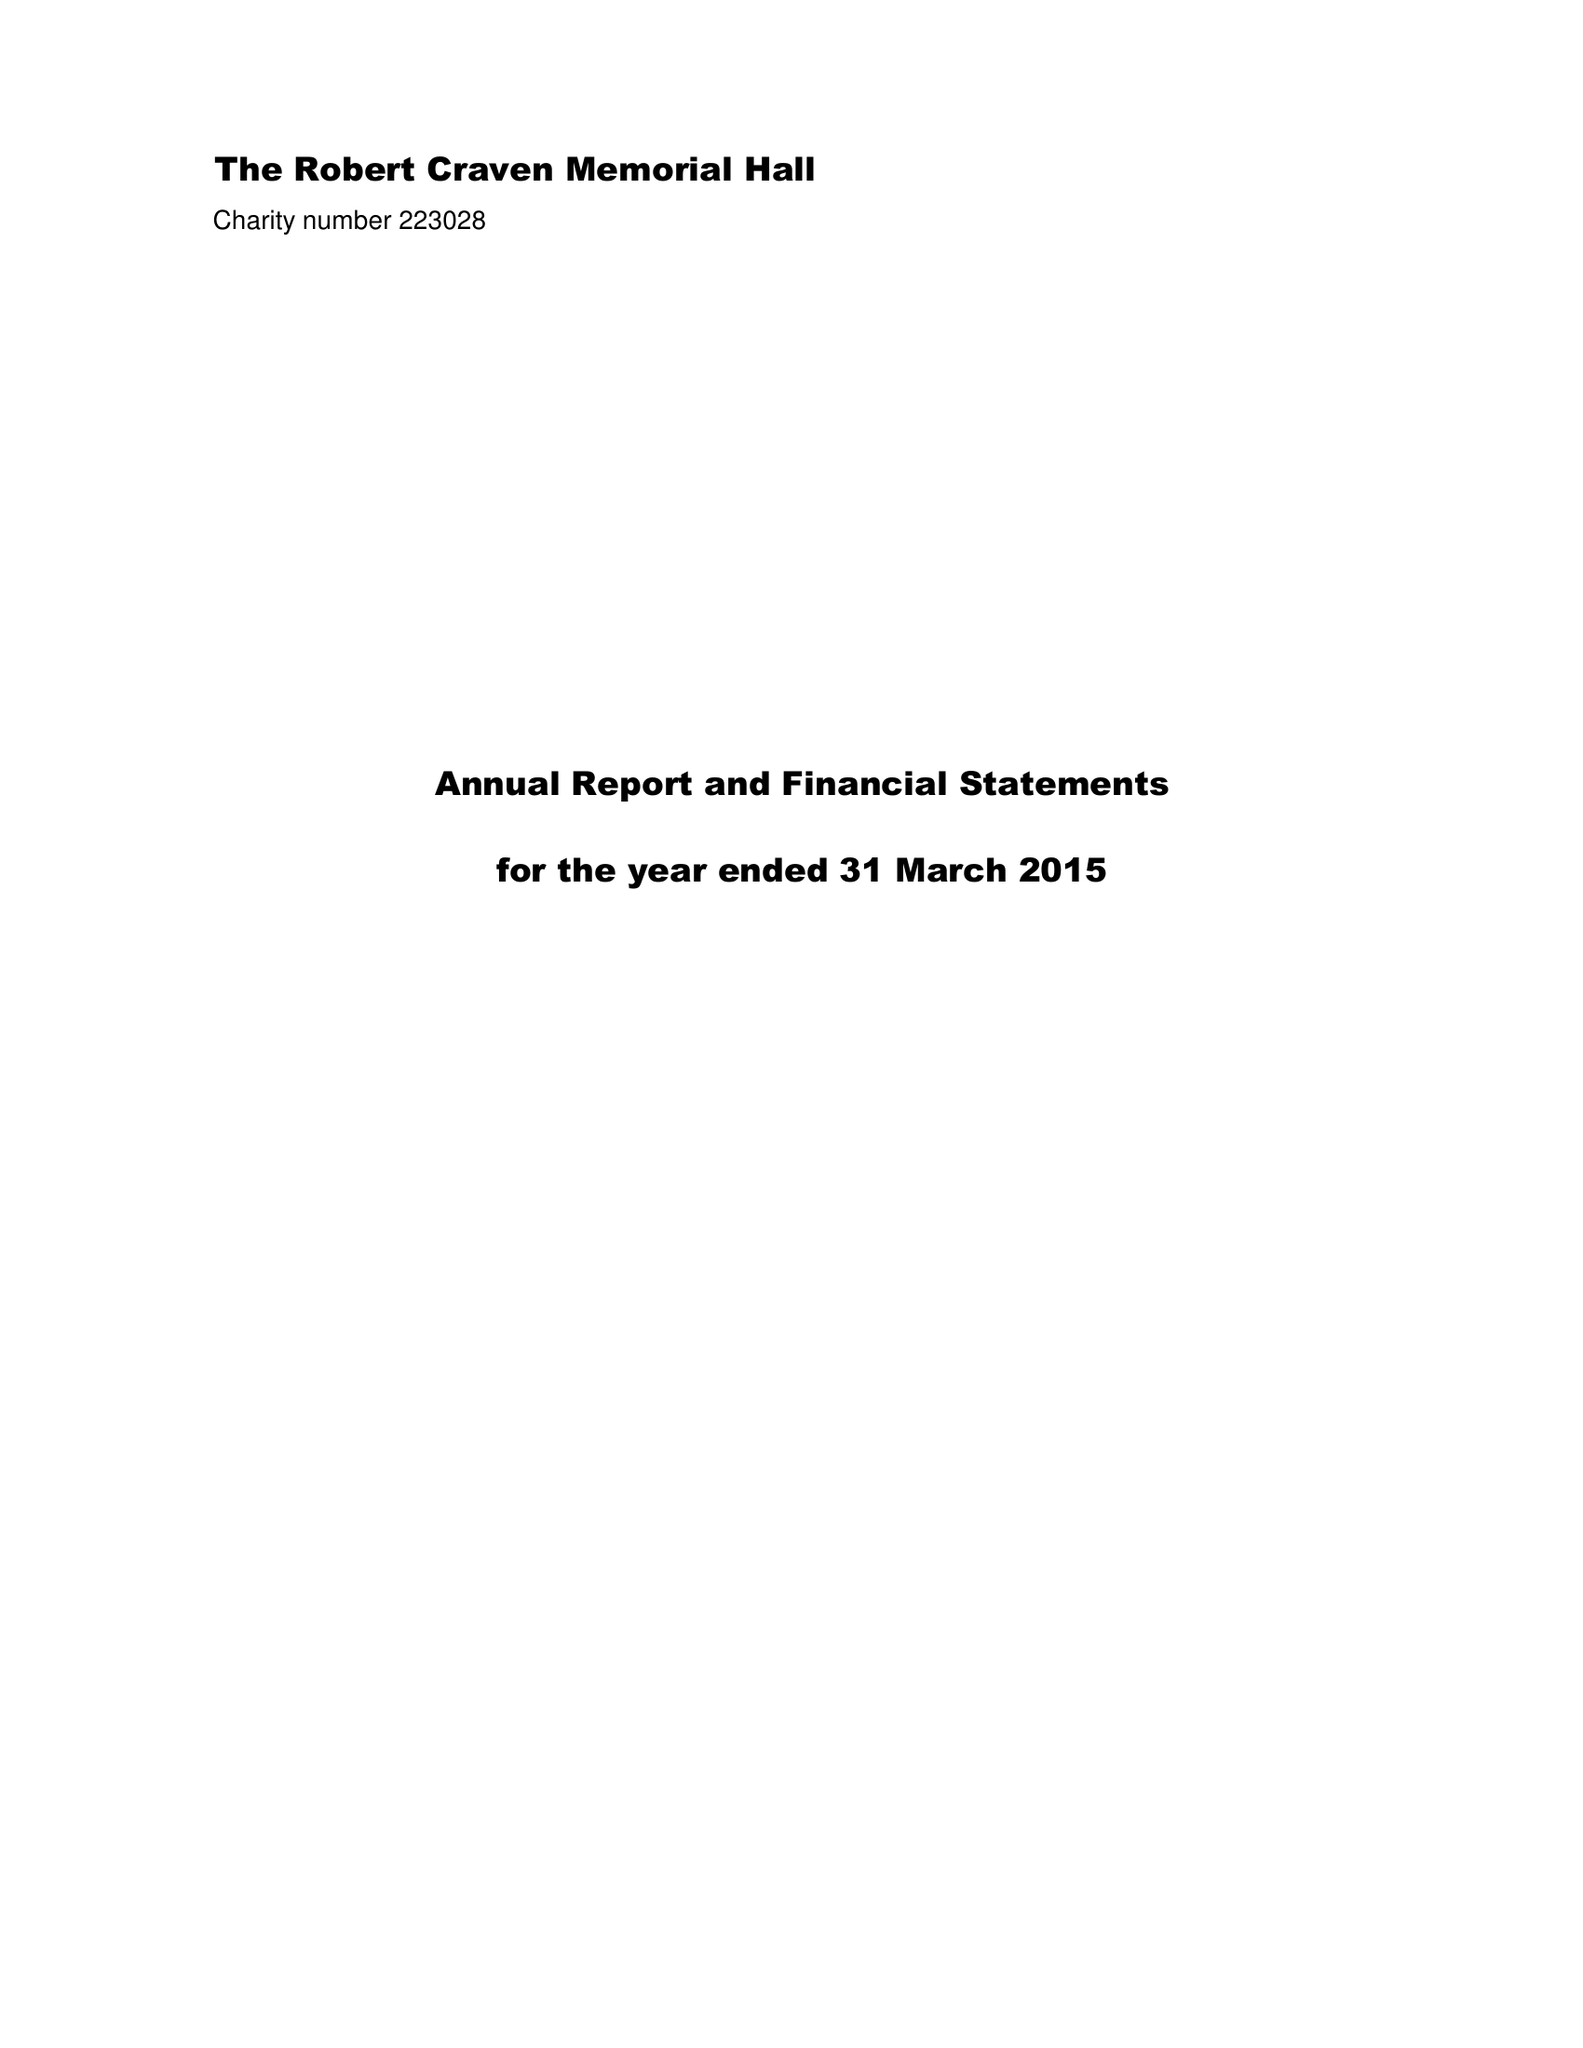What is the value for the report_date?
Answer the question using a single word or phrase. 2015-03-31 